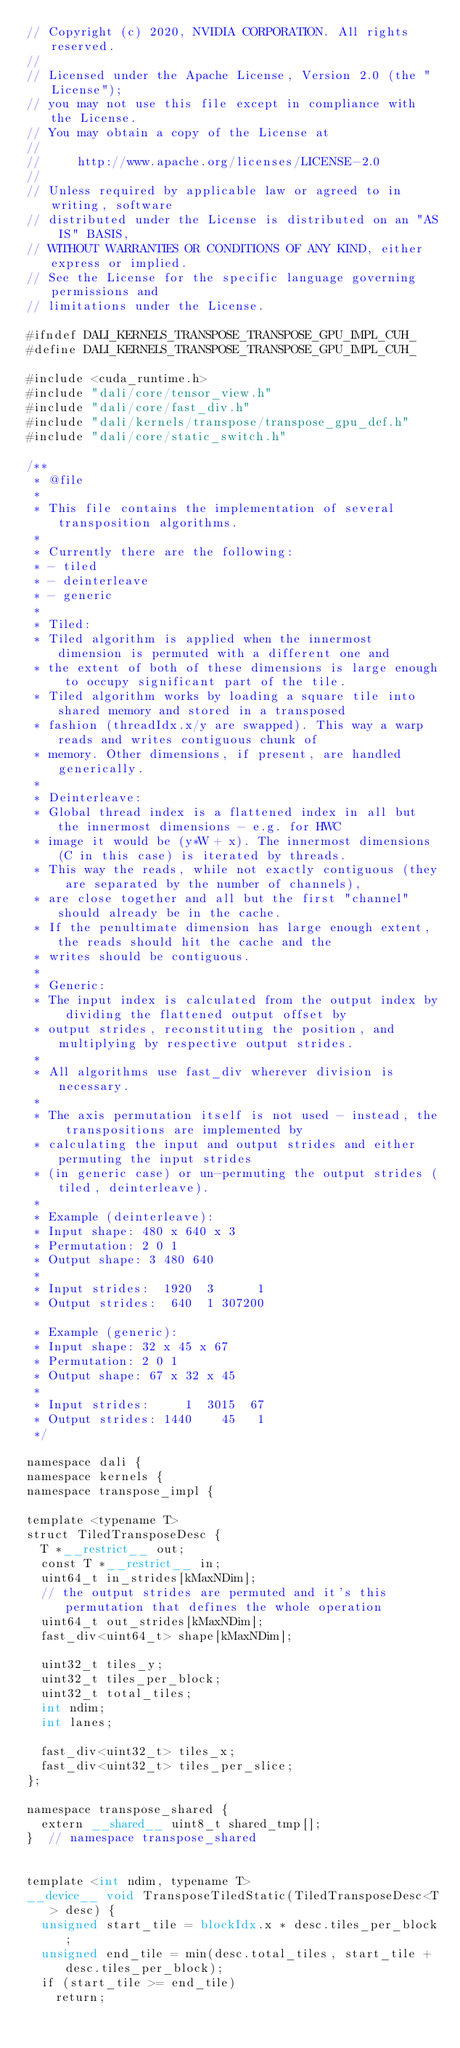Convert code to text. <code><loc_0><loc_0><loc_500><loc_500><_Cuda_>// Copyright (c) 2020, NVIDIA CORPORATION. All rights reserved.
//
// Licensed under the Apache License, Version 2.0 (the "License");
// you may not use this file except in compliance with the License.
// You may obtain a copy of the License at
//
//     http://www.apache.org/licenses/LICENSE-2.0
//
// Unless required by applicable law or agreed to in writing, software
// distributed under the License is distributed on an "AS IS" BASIS,
// WITHOUT WARRANTIES OR CONDITIONS OF ANY KIND, either express or implied.
// See the License for the specific language governing permissions and
// limitations under the License.

#ifndef DALI_KERNELS_TRANSPOSE_TRANSPOSE_GPU_IMPL_CUH_
#define DALI_KERNELS_TRANSPOSE_TRANSPOSE_GPU_IMPL_CUH_

#include <cuda_runtime.h>
#include "dali/core/tensor_view.h"
#include "dali/core/fast_div.h"
#include "dali/kernels/transpose/transpose_gpu_def.h"
#include "dali/core/static_switch.h"

/**
 * @file
 *
 * This file contains the implementation of several transposition algorithms.
 *
 * Currently there are the following:
 * - tiled
 * - deinterleave
 * - generic
 *
 * Tiled:
 * Tiled algorithm is applied when the innermost dimension is permuted with a different one and
 * the extent of both of these dimensions is large enough to occupy significant part of the tile.
 * Tiled algorithm works by loading a square tile into shared memory and stored in a transposed
 * fashion (threadIdx.x/y are swapped). This way a warp reads and writes contiguous chunk of
 * memory. Other dimensions, if present, are handled generically.
 *
 * Deinterleave:
 * Global thread index is a flattened index in all but the innermost dimensions - e.g. for HWC
 * image it would be (y*W + x). The innermost dimensions (C in this case) is iterated by threads.
 * This way the reads, while not exactly contiguous (they are separated by the number of channels),
 * are close together and all but the first "channel" should already be in the cache.
 * If the penultimate dimension has large enough extent, the reads should hit the cache and the
 * writes should be contiguous.
 *
 * Generic:
 * The input index is calculated from the output index by dividing the flattened output offset by
 * output strides, reconstituting the position, and multiplying by respective output strides.
 *
 * All algorithms use fast_div wherever division is necessary.
 *
 * The axis permutation itself is not used - instead, the transpositions are implemented by
 * calculating the input and output strides and either permuting the input strides
 * (in generic case) or un-permuting the output strides (tiled, deinterleave).
 *
 * Example (deinterleave):
 * Input shape: 480 x 640 x 3
 * Permutation: 2 0 1
 * Output shape: 3 480 640
 *
 * Input strides:  1920  3      1
 * Output strides:  640  1 307200

 * Example (generic):
 * Input shape: 32 x 45 x 67
 * Permutation: 2 0 1
 * Output shape: 67 x 32 x 45
 *
 * Input strides:     1  3015  67
 * Output strides: 1440    45   1
 */

namespace dali {
namespace kernels {
namespace transpose_impl {

template <typename T>
struct TiledTransposeDesc {
  T *__restrict__ out;
  const T *__restrict__ in;
  uint64_t in_strides[kMaxNDim];
  // the output strides are permuted and it's this permutation that defines the whole operation
  uint64_t out_strides[kMaxNDim];
  fast_div<uint64_t> shape[kMaxNDim];

  uint32_t tiles_y;
  uint32_t tiles_per_block;
  uint32_t total_tiles;
  int ndim;
  int lanes;

  fast_div<uint32_t> tiles_x;
  fast_div<uint32_t> tiles_per_slice;
};

namespace transpose_shared {
  extern __shared__ uint8_t shared_tmp[];
}  // namespace transpose_shared


template <int ndim, typename T>
__device__ void TransposeTiledStatic(TiledTransposeDesc<T> desc) {
  unsigned start_tile = blockIdx.x * desc.tiles_per_block;
  unsigned end_tile = min(desc.total_tiles, start_tile + desc.tiles_per_block);
  if (start_tile >= end_tile)
    return;
</code> 